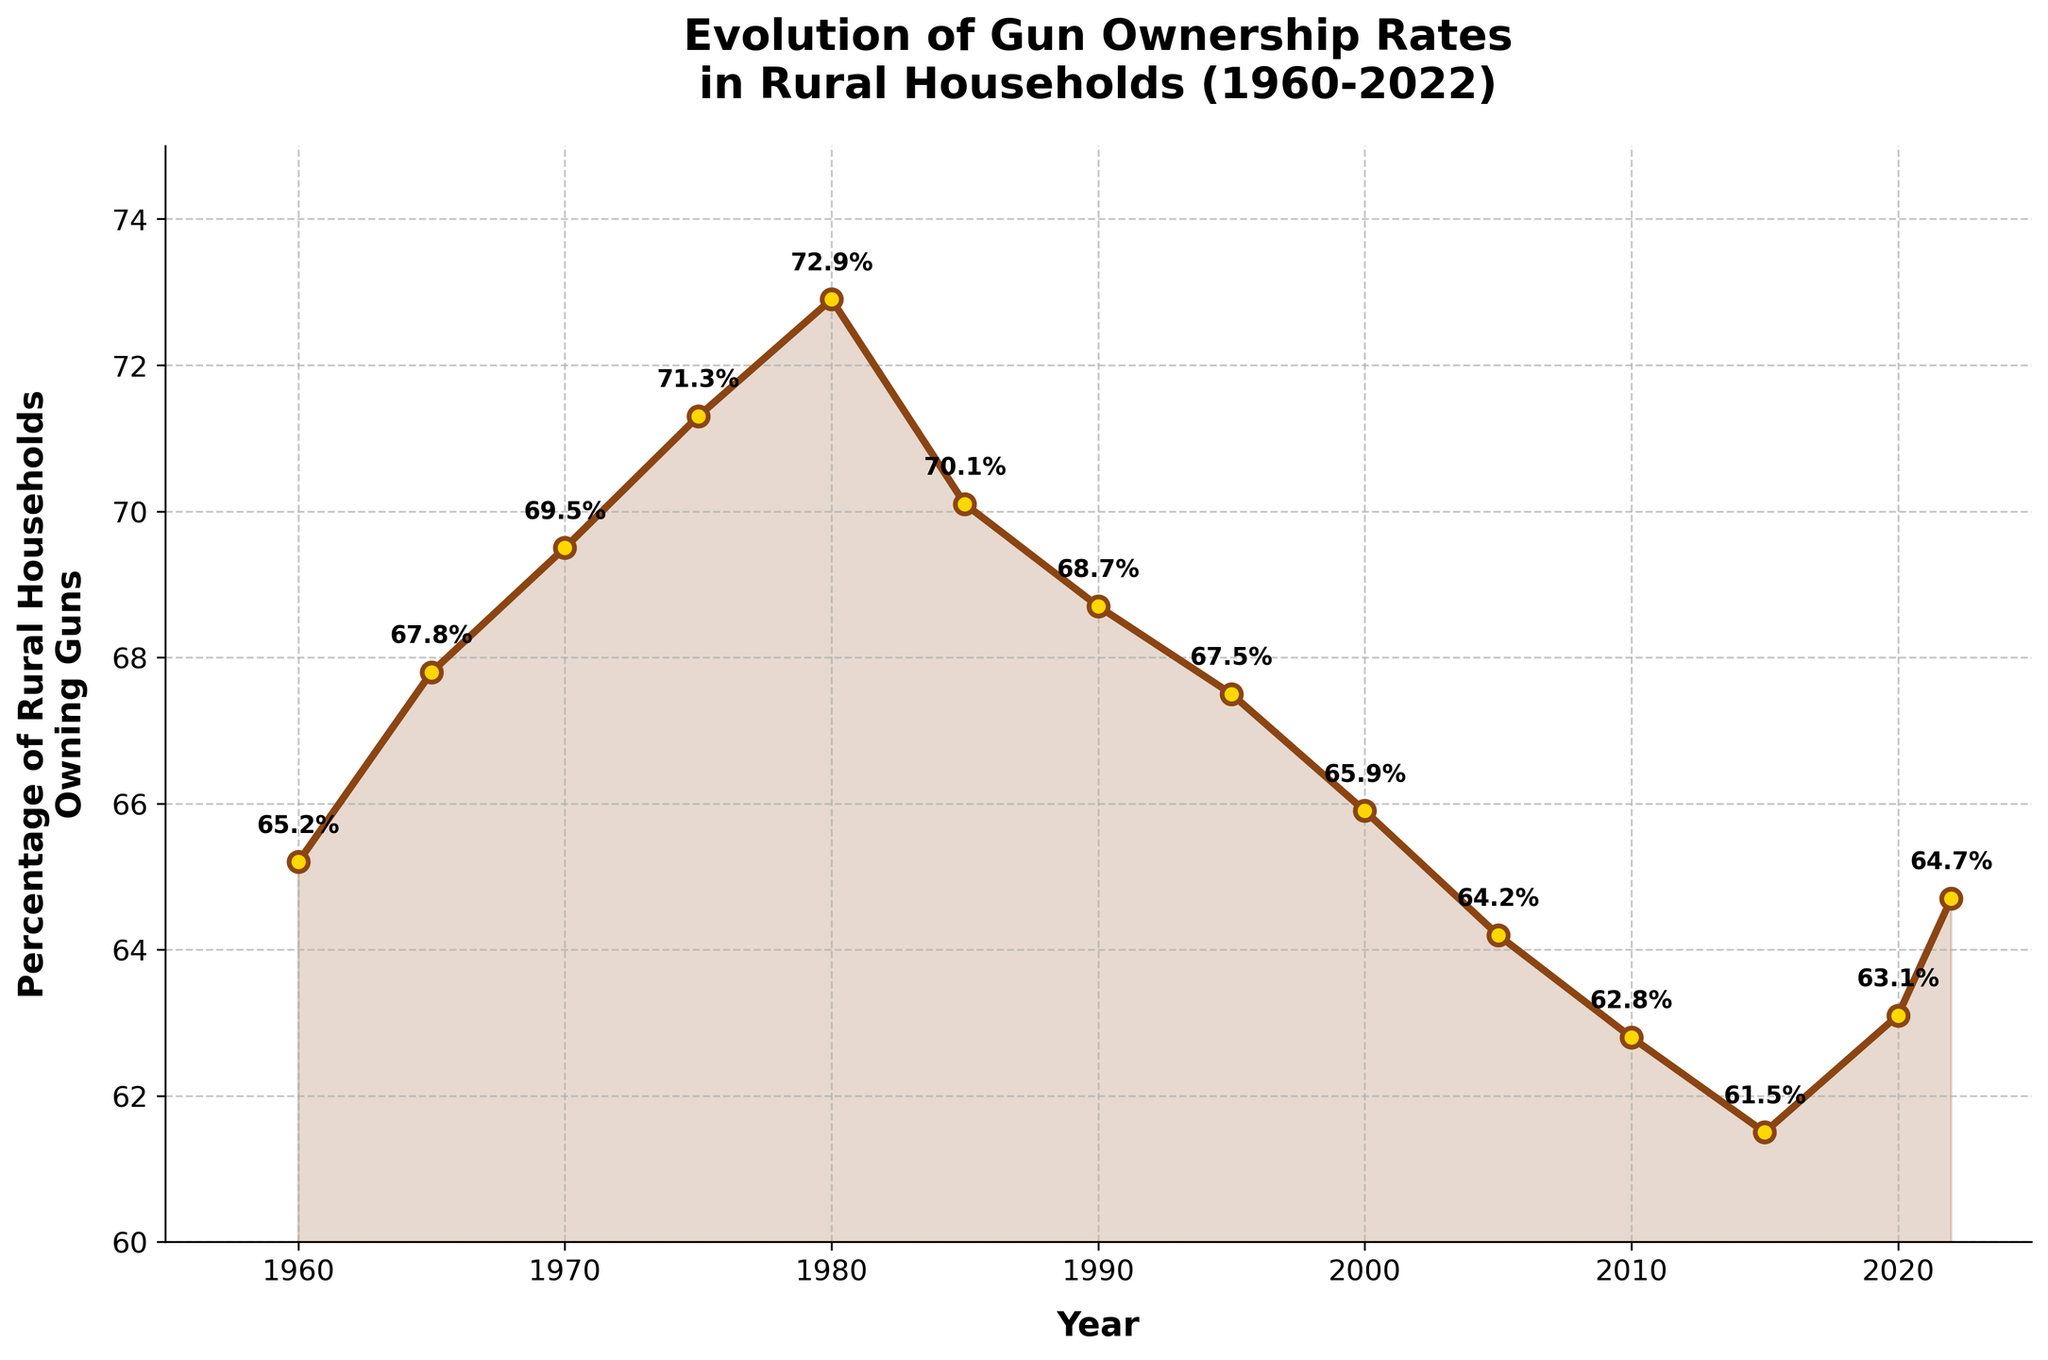What was the highest percentage of rural households owning guns? The highest percentage of gun ownership can be observed by identifying the highest point on the line. From the data, the peak is at the year 1980 with 72.9%.
Answer: 72.9% In which years did the percentage of rural households owning guns increase from the previous year? By examining the line, the percentage increases in the intervals: 1960 to 1965, 1965 to 1970, 1970 to 1975, 1975 to 1980, and 2015 to 2020, and 2020 to 2022. This means the line ascends during these periods.
Answer: 1965, 1970, 1975, 1980, 2020, 2022 What is the difference in gun ownership rates between 1980 and 2005? To find the difference, subtract the percentage in 2005 from that in 1980. The values are 72.9% (1980) and 64.2% (2005). Therefore, the difference is 72.9 - 64.2 = 8.7.
Answer: 8.7% How did gun ownership rates change from 1990 to 2000? From the figure, the percentage in 1990 is 68.7% and in 2000 it is 65.9%. This shows a decrease. The change is 68.7 - 65.9 = 2.8.
Answer: Decreased by 2.8% Which decade saw the largest decline in gun ownership rates? By comparing the intervals, the largest decline is seen in the decade between 1980 to 1990, where there is a drop from 72.9% to 68.7% (4.2%).
Answer: 1980-1990 What is the average percentage of rural households owning guns across all years presented? Add all the percentages and divide by the number of data points (14 years). The sum of percentages is 927.5. So the average is 927.5 / 14 ≈ 66.25%.
Answer: 66.25% Do the percentages ever drop below 61%? Checking the figure, the lowest percentage is shown in 2015 with 61.5%, which does not drop below 61%.
Answer: No Which two years have the smallest difference in gun ownership rates? Comparing the difference between all the consecutive years, the smallest difference is between 2020 (63.1%) and 2022 (64.7%), with a difference of 1.6.
Answer: 2020 and 2022 What visual elements are used to highlight the data points on the chart? The figure uses markers at each data point, with a filled area under the line to highlight the changes over time. Additionally, each data point has an attached label indicating the exact percentage.
Answer: Markers, filled area, labels 